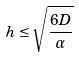Convert formula to latex. <formula><loc_0><loc_0><loc_500><loc_500>h \leq \sqrt { \frac { 6 D } { \alpha } }</formula> 